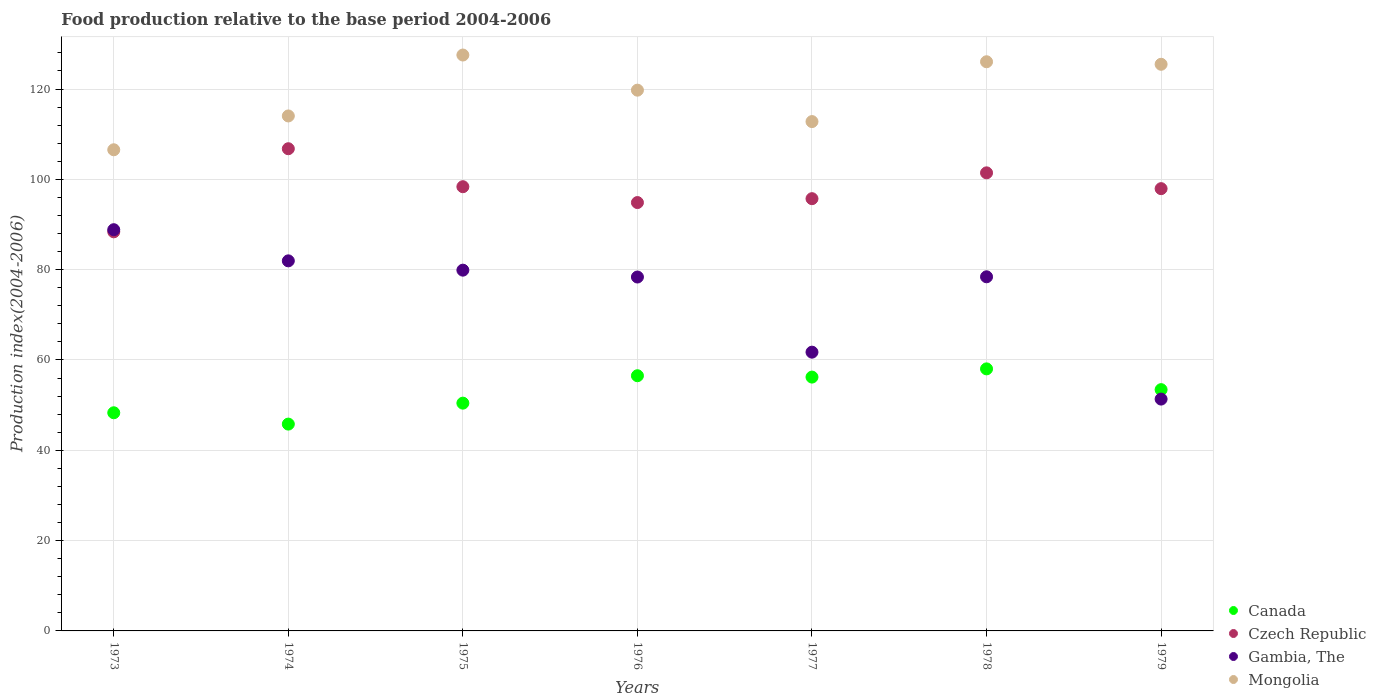What is the food production index in Gambia, The in 1976?
Keep it short and to the point. 78.37. Across all years, what is the maximum food production index in Czech Republic?
Give a very brief answer. 106.78. Across all years, what is the minimum food production index in Czech Republic?
Your response must be concise. 88.38. In which year was the food production index in Canada maximum?
Make the answer very short. 1978. What is the total food production index in Gambia, The in the graph?
Offer a terse response. 520.55. What is the difference between the food production index in Canada in 1973 and that in 1979?
Your answer should be very brief. -5.12. What is the difference between the food production index in Mongolia in 1978 and the food production index in Gambia, The in 1977?
Your response must be concise. 64.31. What is the average food production index in Czech Republic per year?
Your answer should be compact. 97.64. In the year 1978, what is the difference between the food production index in Czech Republic and food production index in Mongolia?
Provide a short and direct response. -24.6. What is the ratio of the food production index in Gambia, The in 1976 to that in 1977?
Ensure brevity in your answer.  1.27. Is the difference between the food production index in Czech Republic in 1974 and 1979 greater than the difference between the food production index in Mongolia in 1974 and 1979?
Your response must be concise. Yes. What is the difference between the highest and the second highest food production index in Mongolia?
Offer a very short reply. 1.49. What is the difference between the highest and the lowest food production index in Czech Republic?
Provide a succinct answer. 18.4. Is the sum of the food production index in Mongolia in 1973 and 1974 greater than the maximum food production index in Gambia, The across all years?
Make the answer very short. Yes. Is it the case that in every year, the sum of the food production index in Mongolia and food production index in Canada  is greater than the food production index in Czech Republic?
Provide a succinct answer. Yes. Is the food production index in Gambia, The strictly greater than the food production index in Czech Republic over the years?
Your response must be concise. No. How many years are there in the graph?
Offer a very short reply. 7. Does the graph contain grids?
Your response must be concise. Yes. Where does the legend appear in the graph?
Ensure brevity in your answer.  Bottom right. How are the legend labels stacked?
Ensure brevity in your answer.  Vertical. What is the title of the graph?
Ensure brevity in your answer.  Food production relative to the base period 2004-2006. Does "Indonesia" appear as one of the legend labels in the graph?
Provide a short and direct response. No. What is the label or title of the Y-axis?
Provide a short and direct response. Production index(2004-2006). What is the Production index(2004-2006) of Canada in 1973?
Provide a short and direct response. 48.31. What is the Production index(2004-2006) of Czech Republic in 1973?
Your response must be concise. 88.38. What is the Production index(2004-2006) in Gambia, The in 1973?
Give a very brief answer. 88.85. What is the Production index(2004-2006) in Mongolia in 1973?
Your answer should be very brief. 106.55. What is the Production index(2004-2006) in Canada in 1974?
Your answer should be very brief. 45.8. What is the Production index(2004-2006) in Czech Republic in 1974?
Ensure brevity in your answer.  106.78. What is the Production index(2004-2006) of Gambia, The in 1974?
Give a very brief answer. 81.95. What is the Production index(2004-2006) in Mongolia in 1974?
Provide a succinct answer. 114.04. What is the Production index(2004-2006) of Canada in 1975?
Provide a succinct answer. 50.44. What is the Production index(2004-2006) of Czech Republic in 1975?
Provide a succinct answer. 98.37. What is the Production index(2004-2006) of Gambia, The in 1975?
Your response must be concise. 79.89. What is the Production index(2004-2006) in Mongolia in 1975?
Keep it short and to the point. 127.53. What is the Production index(2004-2006) in Canada in 1976?
Provide a succinct answer. 56.51. What is the Production index(2004-2006) of Czech Republic in 1976?
Offer a very short reply. 94.86. What is the Production index(2004-2006) in Gambia, The in 1976?
Your answer should be compact. 78.37. What is the Production index(2004-2006) in Mongolia in 1976?
Provide a short and direct response. 119.75. What is the Production index(2004-2006) of Canada in 1977?
Keep it short and to the point. 56.21. What is the Production index(2004-2006) of Czech Republic in 1977?
Offer a terse response. 95.72. What is the Production index(2004-2006) in Gambia, The in 1977?
Provide a succinct answer. 61.73. What is the Production index(2004-2006) of Mongolia in 1977?
Offer a very short reply. 112.79. What is the Production index(2004-2006) of Canada in 1978?
Provide a short and direct response. 58.03. What is the Production index(2004-2006) of Czech Republic in 1978?
Keep it short and to the point. 101.44. What is the Production index(2004-2006) of Gambia, The in 1978?
Provide a short and direct response. 78.42. What is the Production index(2004-2006) of Mongolia in 1978?
Ensure brevity in your answer.  126.04. What is the Production index(2004-2006) in Canada in 1979?
Your response must be concise. 53.43. What is the Production index(2004-2006) in Czech Republic in 1979?
Your answer should be compact. 97.94. What is the Production index(2004-2006) in Gambia, The in 1979?
Your answer should be very brief. 51.34. What is the Production index(2004-2006) in Mongolia in 1979?
Provide a short and direct response. 125.48. Across all years, what is the maximum Production index(2004-2006) in Canada?
Make the answer very short. 58.03. Across all years, what is the maximum Production index(2004-2006) of Czech Republic?
Provide a short and direct response. 106.78. Across all years, what is the maximum Production index(2004-2006) of Gambia, The?
Your answer should be very brief. 88.85. Across all years, what is the maximum Production index(2004-2006) of Mongolia?
Your response must be concise. 127.53. Across all years, what is the minimum Production index(2004-2006) in Canada?
Your answer should be compact. 45.8. Across all years, what is the minimum Production index(2004-2006) of Czech Republic?
Your answer should be very brief. 88.38. Across all years, what is the minimum Production index(2004-2006) of Gambia, The?
Give a very brief answer. 51.34. Across all years, what is the minimum Production index(2004-2006) of Mongolia?
Your response must be concise. 106.55. What is the total Production index(2004-2006) in Canada in the graph?
Make the answer very short. 368.73. What is the total Production index(2004-2006) in Czech Republic in the graph?
Your response must be concise. 683.49. What is the total Production index(2004-2006) in Gambia, The in the graph?
Your answer should be compact. 520.55. What is the total Production index(2004-2006) of Mongolia in the graph?
Offer a terse response. 832.18. What is the difference between the Production index(2004-2006) in Canada in 1973 and that in 1974?
Offer a very short reply. 2.51. What is the difference between the Production index(2004-2006) in Czech Republic in 1973 and that in 1974?
Provide a short and direct response. -18.4. What is the difference between the Production index(2004-2006) in Gambia, The in 1973 and that in 1974?
Offer a terse response. 6.9. What is the difference between the Production index(2004-2006) in Mongolia in 1973 and that in 1974?
Offer a terse response. -7.49. What is the difference between the Production index(2004-2006) in Canada in 1973 and that in 1975?
Provide a short and direct response. -2.13. What is the difference between the Production index(2004-2006) in Czech Republic in 1973 and that in 1975?
Offer a terse response. -9.99. What is the difference between the Production index(2004-2006) of Gambia, The in 1973 and that in 1975?
Give a very brief answer. 8.96. What is the difference between the Production index(2004-2006) of Mongolia in 1973 and that in 1975?
Your answer should be very brief. -20.98. What is the difference between the Production index(2004-2006) of Canada in 1973 and that in 1976?
Provide a succinct answer. -8.2. What is the difference between the Production index(2004-2006) in Czech Republic in 1973 and that in 1976?
Provide a succinct answer. -6.48. What is the difference between the Production index(2004-2006) of Gambia, The in 1973 and that in 1976?
Give a very brief answer. 10.48. What is the difference between the Production index(2004-2006) of Mongolia in 1973 and that in 1976?
Keep it short and to the point. -13.2. What is the difference between the Production index(2004-2006) of Canada in 1973 and that in 1977?
Offer a terse response. -7.9. What is the difference between the Production index(2004-2006) in Czech Republic in 1973 and that in 1977?
Provide a succinct answer. -7.34. What is the difference between the Production index(2004-2006) in Gambia, The in 1973 and that in 1977?
Make the answer very short. 27.12. What is the difference between the Production index(2004-2006) of Mongolia in 1973 and that in 1977?
Ensure brevity in your answer.  -6.24. What is the difference between the Production index(2004-2006) of Canada in 1973 and that in 1978?
Your answer should be very brief. -9.72. What is the difference between the Production index(2004-2006) in Czech Republic in 1973 and that in 1978?
Give a very brief answer. -13.06. What is the difference between the Production index(2004-2006) in Gambia, The in 1973 and that in 1978?
Provide a short and direct response. 10.43. What is the difference between the Production index(2004-2006) in Mongolia in 1973 and that in 1978?
Your answer should be compact. -19.49. What is the difference between the Production index(2004-2006) in Canada in 1973 and that in 1979?
Ensure brevity in your answer.  -5.12. What is the difference between the Production index(2004-2006) of Czech Republic in 1973 and that in 1979?
Make the answer very short. -9.56. What is the difference between the Production index(2004-2006) of Gambia, The in 1973 and that in 1979?
Your answer should be compact. 37.51. What is the difference between the Production index(2004-2006) of Mongolia in 1973 and that in 1979?
Your response must be concise. -18.93. What is the difference between the Production index(2004-2006) of Canada in 1974 and that in 1975?
Offer a terse response. -4.64. What is the difference between the Production index(2004-2006) of Czech Republic in 1974 and that in 1975?
Keep it short and to the point. 8.41. What is the difference between the Production index(2004-2006) of Gambia, The in 1974 and that in 1975?
Your answer should be compact. 2.06. What is the difference between the Production index(2004-2006) of Mongolia in 1974 and that in 1975?
Make the answer very short. -13.49. What is the difference between the Production index(2004-2006) of Canada in 1974 and that in 1976?
Offer a terse response. -10.71. What is the difference between the Production index(2004-2006) of Czech Republic in 1974 and that in 1976?
Your answer should be compact. 11.92. What is the difference between the Production index(2004-2006) of Gambia, The in 1974 and that in 1976?
Your answer should be compact. 3.58. What is the difference between the Production index(2004-2006) of Mongolia in 1974 and that in 1976?
Offer a terse response. -5.71. What is the difference between the Production index(2004-2006) in Canada in 1974 and that in 1977?
Keep it short and to the point. -10.41. What is the difference between the Production index(2004-2006) of Czech Republic in 1974 and that in 1977?
Offer a terse response. 11.06. What is the difference between the Production index(2004-2006) in Gambia, The in 1974 and that in 1977?
Your answer should be very brief. 20.22. What is the difference between the Production index(2004-2006) in Mongolia in 1974 and that in 1977?
Provide a succinct answer. 1.25. What is the difference between the Production index(2004-2006) in Canada in 1974 and that in 1978?
Make the answer very short. -12.23. What is the difference between the Production index(2004-2006) of Czech Republic in 1974 and that in 1978?
Make the answer very short. 5.34. What is the difference between the Production index(2004-2006) of Gambia, The in 1974 and that in 1978?
Your response must be concise. 3.53. What is the difference between the Production index(2004-2006) of Canada in 1974 and that in 1979?
Provide a short and direct response. -7.63. What is the difference between the Production index(2004-2006) in Czech Republic in 1974 and that in 1979?
Your answer should be compact. 8.84. What is the difference between the Production index(2004-2006) in Gambia, The in 1974 and that in 1979?
Provide a short and direct response. 30.61. What is the difference between the Production index(2004-2006) of Mongolia in 1974 and that in 1979?
Your response must be concise. -11.44. What is the difference between the Production index(2004-2006) in Canada in 1975 and that in 1976?
Provide a short and direct response. -6.07. What is the difference between the Production index(2004-2006) in Czech Republic in 1975 and that in 1976?
Your answer should be very brief. 3.51. What is the difference between the Production index(2004-2006) in Gambia, The in 1975 and that in 1976?
Ensure brevity in your answer.  1.52. What is the difference between the Production index(2004-2006) in Mongolia in 1975 and that in 1976?
Offer a very short reply. 7.78. What is the difference between the Production index(2004-2006) of Canada in 1975 and that in 1977?
Your answer should be compact. -5.77. What is the difference between the Production index(2004-2006) in Czech Republic in 1975 and that in 1977?
Provide a succinct answer. 2.65. What is the difference between the Production index(2004-2006) in Gambia, The in 1975 and that in 1977?
Give a very brief answer. 18.16. What is the difference between the Production index(2004-2006) in Mongolia in 1975 and that in 1977?
Your answer should be very brief. 14.74. What is the difference between the Production index(2004-2006) in Canada in 1975 and that in 1978?
Provide a succinct answer. -7.59. What is the difference between the Production index(2004-2006) in Czech Republic in 1975 and that in 1978?
Your answer should be compact. -3.07. What is the difference between the Production index(2004-2006) of Gambia, The in 1975 and that in 1978?
Keep it short and to the point. 1.47. What is the difference between the Production index(2004-2006) in Mongolia in 1975 and that in 1978?
Keep it short and to the point. 1.49. What is the difference between the Production index(2004-2006) of Canada in 1975 and that in 1979?
Provide a short and direct response. -2.99. What is the difference between the Production index(2004-2006) of Czech Republic in 1975 and that in 1979?
Provide a succinct answer. 0.43. What is the difference between the Production index(2004-2006) of Gambia, The in 1975 and that in 1979?
Make the answer very short. 28.55. What is the difference between the Production index(2004-2006) of Mongolia in 1975 and that in 1979?
Give a very brief answer. 2.05. What is the difference between the Production index(2004-2006) of Canada in 1976 and that in 1977?
Your answer should be very brief. 0.3. What is the difference between the Production index(2004-2006) of Czech Republic in 1976 and that in 1977?
Your response must be concise. -0.86. What is the difference between the Production index(2004-2006) in Gambia, The in 1976 and that in 1977?
Ensure brevity in your answer.  16.64. What is the difference between the Production index(2004-2006) in Mongolia in 1976 and that in 1977?
Your answer should be compact. 6.96. What is the difference between the Production index(2004-2006) in Canada in 1976 and that in 1978?
Offer a terse response. -1.52. What is the difference between the Production index(2004-2006) of Czech Republic in 1976 and that in 1978?
Give a very brief answer. -6.58. What is the difference between the Production index(2004-2006) in Mongolia in 1976 and that in 1978?
Your answer should be compact. -6.29. What is the difference between the Production index(2004-2006) in Canada in 1976 and that in 1979?
Offer a very short reply. 3.08. What is the difference between the Production index(2004-2006) in Czech Republic in 1976 and that in 1979?
Make the answer very short. -3.08. What is the difference between the Production index(2004-2006) of Gambia, The in 1976 and that in 1979?
Your response must be concise. 27.03. What is the difference between the Production index(2004-2006) in Mongolia in 1976 and that in 1979?
Ensure brevity in your answer.  -5.73. What is the difference between the Production index(2004-2006) in Canada in 1977 and that in 1978?
Give a very brief answer. -1.82. What is the difference between the Production index(2004-2006) in Czech Republic in 1977 and that in 1978?
Your answer should be very brief. -5.72. What is the difference between the Production index(2004-2006) of Gambia, The in 1977 and that in 1978?
Make the answer very short. -16.69. What is the difference between the Production index(2004-2006) of Mongolia in 1977 and that in 1978?
Your response must be concise. -13.25. What is the difference between the Production index(2004-2006) of Canada in 1977 and that in 1979?
Offer a terse response. 2.78. What is the difference between the Production index(2004-2006) in Czech Republic in 1977 and that in 1979?
Ensure brevity in your answer.  -2.22. What is the difference between the Production index(2004-2006) in Gambia, The in 1977 and that in 1979?
Your answer should be very brief. 10.39. What is the difference between the Production index(2004-2006) in Mongolia in 1977 and that in 1979?
Your answer should be very brief. -12.69. What is the difference between the Production index(2004-2006) of Canada in 1978 and that in 1979?
Offer a very short reply. 4.6. What is the difference between the Production index(2004-2006) in Gambia, The in 1978 and that in 1979?
Your response must be concise. 27.08. What is the difference between the Production index(2004-2006) of Mongolia in 1978 and that in 1979?
Your answer should be very brief. 0.56. What is the difference between the Production index(2004-2006) in Canada in 1973 and the Production index(2004-2006) in Czech Republic in 1974?
Ensure brevity in your answer.  -58.47. What is the difference between the Production index(2004-2006) in Canada in 1973 and the Production index(2004-2006) in Gambia, The in 1974?
Your answer should be compact. -33.64. What is the difference between the Production index(2004-2006) of Canada in 1973 and the Production index(2004-2006) of Mongolia in 1974?
Offer a terse response. -65.73. What is the difference between the Production index(2004-2006) of Czech Republic in 1973 and the Production index(2004-2006) of Gambia, The in 1974?
Your answer should be very brief. 6.43. What is the difference between the Production index(2004-2006) of Czech Republic in 1973 and the Production index(2004-2006) of Mongolia in 1974?
Your answer should be very brief. -25.66. What is the difference between the Production index(2004-2006) in Gambia, The in 1973 and the Production index(2004-2006) in Mongolia in 1974?
Offer a terse response. -25.19. What is the difference between the Production index(2004-2006) in Canada in 1973 and the Production index(2004-2006) in Czech Republic in 1975?
Provide a short and direct response. -50.06. What is the difference between the Production index(2004-2006) in Canada in 1973 and the Production index(2004-2006) in Gambia, The in 1975?
Make the answer very short. -31.58. What is the difference between the Production index(2004-2006) of Canada in 1973 and the Production index(2004-2006) of Mongolia in 1975?
Give a very brief answer. -79.22. What is the difference between the Production index(2004-2006) in Czech Republic in 1973 and the Production index(2004-2006) in Gambia, The in 1975?
Provide a succinct answer. 8.49. What is the difference between the Production index(2004-2006) of Czech Republic in 1973 and the Production index(2004-2006) of Mongolia in 1975?
Provide a succinct answer. -39.15. What is the difference between the Production index(2004-2006) in Gambia, The in 1973 and the Production index(2004-2006) in Mongolia in 1975?
Offer a terse response. -38.68. What is the difference between the Production index(2004-2006) in Canada in 1973 and the Production index(2004-2006) in Czech Republic in 1976?
Offer a terse response. -46.55. What is the difference between the Production index(2004-2006) in Canada in 1973 and the Production index(2004-2006) in Gambia, The in 1976?
Provide a short and direct response. -30.06. What is the difference between the Production index(2004-2006) of Canada in 1973 and the Production index(2004-2006) of Mongolia in 1976?
Keep it short and to the point. -71.44. What is the difference between the Production index(2004-2006) of Czech Republic in 1973 and the Production index(2004-2006) of Gambia, The in 1976?
Offer a very short reply. 10.01. What is the difference between the Production index(2004-2006) of Czech Republic in 1973 and the Production index(2004-2006) of Mongolia in 1976?
Provide a short and direct response. -31.37. What is the difference between the Production index(2004-2006) of Gambia, The in 1973 and the Production index(2004-2006) of Mongolia in 1976?
Your answer should be very brief. -30.9. What is the difference between the Production index(2004-2006) of Canada in 1973 and the Production index(2004-2006) of Czech Republic in 1977?
Ensure brevity in your answer.  -47.41. What is the difference between the Production index(2004-2006) of Canada in 1973 and the Production index(2004-2006) of Gambia, The in 1977?
Offer a terse response. -13.42. What is the difference between the Production index(2004-2006) in Canada in 1973 and the Production index(2004-2006) in Mongolia in 1977?
Offer a terse response. -64.48. What is the difference between the Production index(2004-2006) of Czech Republic in 1973 and the Production index(2004-2006) of Gambia, The in 1977?
Your answer should be compact. 26.65. What is the difference between the Production index(2004-2006) of Czech Republic in 1973 and the Production index(2004-2006) of Mongolia in 1977?
Make the answer very short. -24.41. What is the difference between the Production index(2004-2006) of Gambia, The in 1973 and the Production index(2004-2006) of Mongolia in 1977?
Your response must be concise. -23.94. What is the difference between the Production index(2004-2006) in Canada in 1973 and the Production index(2004-2006) in Czech Republic in 1978?
Ensure brevity in your answer.  -53.13. What is the difference between the Production index(2004-2006) of Canada in 1973 and the Production index(2004-2006) of Gambia, The in 1978?
Your answer should be very brief. -30.11. What is the difference between the Production index(2004-2006) of Canada in 1973 and the Production index(2004-2006) of Mongolia in 1978?
Your answer should be very brief. -77.73. What is the difference between the Production index(2004-2006) of Czech Republic in 1973 and the Production index(2004-2006) of Gambia, The in 1978?
Your answer should be very brief. 9.96. What is the difference between the Production index(2004-2006) of Czech Republic in 1973 and the Production index(2004-2006) of Mongolia in 1978?
Provide a short and direct response. -37.66. What is the difference between the Production index(2004-2006) of Gambia, The in 1973 and the Production index(2004-2006) of Mongolia in 1978?
Provide a short and direct response. -37.19. What is the difference between the Production index(2004-2006) of Canada in 1973 and the Production index(2004-2006) of Czech Republic in 1979?
Your response must be concise. -49.63. What is the difference between the Production index(2004-2006) of Canada in 1973 and the Production index(2004-2006) of Gambia, The in 1979?
Ensure brevity in your answer.  -3.03. What is the difference between the Production index(2004-2006) in Canada in 1973 and the Production index(2004-2006) in Mongolia in 1979?
Give a very brief answer. -77.17. What is the difference between the Production index(2004-2006) in Czech Republic in 1973 and the Production index(2004-2006) in Gambia, The in 1979?
Give a very brief answer. 37.04. What is the difference between the Production index(2004-2006) in Czech Republic in 1973 and the Production index(2004-2006) in Mongolia in 1979?
Offer a very short reply. -37.1. What is the difference between the Production index(2004-2006) of Gambia, The in 1973 and the Production index(2004-2006) of Mongolia in 1979?
Offer a very short reply. -36.63. What is the difference between the Production index(2004-2006) of Canada in 1974 and the Production index(2004-2006) of Czech Republic in 1975?
Ensure brevity in your answer.  -52.57. What is the difference between the Production index(2004-2006) in Canada in 1974 and the Production index(2004-2006) in Gambia, The in 1975?
Offer a terse response. -34.09. What is the difference between the Production index(2004-2006) of Canada in 1974 and the Production index(2004-2006) of Mongolia in 1975?
Provide a succinct answer. -81.73. What is the difference between the Production index(2004-2006) of Czech Republic in 1974 and the Production index(2004-2006) of Gambia, The in 1975?
Give a very brief answer. 26.89. What is the difference between the Production index(2004-2006) in Czech Republic in 1974 and the Production index(2004-2006) in Mongolia in 1975?
Keep it short and to the point. -20.75. What is the difference between the Production index(2004-2006) of Gambia, The in 1974 and the Production index(2004-2006) of Mongolia in 1975?
Make the answer very short. -45.58. What is the difference between the Production index(2004-2006) of Canada in 1974 and the Production index(2004-2006) of Czech Republic in 1976?
Your answer should be very brief. -49.06. What is the difference between the Production index(2004-2006) in Canada in 1974 and the Production index(2004-2006) in Gambia, The in 1976?
Your answer should be compact. -32.57. What is the difference between the Production index(2004-2006) of Canada in 1974 and the Production index(2004-2006) of Mongolia in 1976?
Provide a succinct answer. -73.95. What is the difference between the Production index(2004-2006) of Czech Republic in 1974 and the Production index(2004-2006) of Gambia, The in 1976?
Ensure brevity in your answer.  28.41. What is the difference between the Production index(2004-2006) of Czech Republic in 1974 and the Production index(2004-2006) of Mongolia in 1976?
Offer a very short reply. -12.97. What is the difference between the Production index(2004-2006) in Gambia, The in 1974 and the Production index(2004-2006) in Mongolia in 1976?
Provide a succinct answer. -37.8. What is the difference between the Production index(2004-2006) in Canada in 1974 and the Production index(2004-2006) in Czech Republic in 1977?
Your answer should be compact. -49.92. What is the difference between the Production index(2004-2006) in Canada in 1974 and the Production index(2004-2006) in Gambia, The in 1977?
Provide a short and direct response. -15.93. What is the difference between the Production index(2004-2006) of Canada in 1974 and the Production index(2004-2006) of Mongolia in 1977?
Offer a terse response. -66.99. What is the difference between the Production index(2004-2006) in Czech Republic in 1974 and the Production index(2004-2006) in Gambia, The in 1977?
Offer a very short reply. 45.05. What is the difference between the Production index(2004-2006) in Czech Republic in 1974 and the Production index(2004-2006) in Mongolia in 1977?
Offer a terse response. -6.01. What is the difference between the Production index(2004-2006) in Gambia, The in 1974 and the Production index(2004-2006) in Mongolia in 1977?
Offer a terse response. -30.84. What is the difference between the Production index(2004-2006) of Canada in 1974 and the Production index(2004-2006) of Czech Republic in 1978?
Your answer should be compact. -55.64. What is the difference between the Production index(2004-2006) in Canada in 1974 and the Production index(2004-2006) in Gambia, The in 1978?
Offer a terse response. -32.62. What is the difference between the Production index(2004-2006) in Canada in 1974 and the Production index(2004-2006) in Mongolia in 1978?
Provide a short and direct response. -80.24. What is the difference between the Production index(2004-2006) of Czech Republic in 1974 and the Production index(2004-2006) of Gambia, The in 1978?
Offer a terse response. 28.36. What is the difference between the Production index(2004-2006) of Czech Republic in 1974 and the Production index(2004-2006) of Mongolia in 1978?
Your answer should be compact. -19.26. What is the difference between the Production index(2004-2006) in Gambia, The in 1974 and the Production index(2004-2006) in Mongolia in 1978?
Provide a succinct answer. -44.09. What is the difference between the Production index(2004-2006) of Canada in 1974 and the Production index(2004-2006) of Czech Republic in 1979?
Your answer should be very brief. -52.14. What is the difference between the Production index(2004-2006) of Canada in 1974 and the Production index(2004-2006) of Gambia, The in 1979?
Your answer should be compact. -5.54. What is the difference between the Production index(2004-2006) in Canada in 1974 and the Production index(2004-2006) in Mongolia in 1979?
Keep it short and to the point. -79.68. What is the difference between the Production index(2004-2006) of Czech Republic in 1974 and the Production index(2004-2006) of Gambia, The in 1979?
Your response must be concise. 55.44. What is the difference between the Production index(2004-2006) of Czech Republic in 1974 and the Production index(2004-2006) of Mongolia in 1979?
Keep it short and to the point. -18.7. What is the difference between the Production index(2004-2006) of Gambia, The in 1974 and the Production index(2004-2006) of Mongolia in 1979?
Your response must be concise. -43.53. What is the difference between the Production index(2004-2006) of Canada in 1975 and the Production index(2004-2006) of Czech Republic in 1976?
Keep it short and to the point. -44.42. What is the difference between the Production index(2004-2006) in Canada in 1975 and the Production index(2004-2006) in Gambia, The in 1976?
Ensure brevity in your answer.  -27.93. What is the difference between the Production index(2004-2006) in Canada in 1975 and the Production index(2004-2006) in Mongolia in 1976?
Provide a short and direct response. -69.31. What is the difference between the Production index(2004-2006) of Czech Republic in 1975 and the Production index(2004-2006) of Gambia, The in 1976?
Ensure brevity in your answer.  20. What is the difference between the Production index(2004-2006) in Czech Republic in 1975 and the Production index(2004-2006) in Mongolia in 1976?
Offer a very short reply. -21.38. What is the difference between the Production index(2004-2006) of Gambia, The in 1975 and the Production index(2004-2006) of Mongolia in 1976?
Provide a short and direct response. -39.86. What is the difference between the Production index(2004-2006) in Canada in 1975 and the Production index(2004-2006) in Czech Republic in 1977?
Give a very brief answer. -45.28. What is the difference between the Production index(2004-2006) in Canada in 1975 and the Production index(2004-2006) in Gambia, The in 1977?
Keep it short and to the point. -11.29. What is the difference between the Production index(2004-2006) in Canada in 1975 and the Production index(2004-2006) in Mongolia in 1977?
Your response must be concise. -62.35. What is the difference between the Production index(2004-2006) in Czech Republic in 1975 and the Production index(2004-2006) in Gambia, The in 1977?
Offer a very short reply. 36.64. What is the difference between the Production index(2004-2006) of Czech Republic in 1975 and the Production index(2004-2006) of Mongolia in 1977?
Keep it short and to the point. -14.42. What is the difference between the Production index(2004-2006) of Gambia, The in 1975 and the Production index(2004-2006) of Mongolia in 1977?
Ensure brevity in your answer.  -32.9. What is the difference between the Production index(2004-2006) in Canada in 1975 and the Production index(2004-2006) in Czech Republic in 1978?
Keep it short and to the point. -51. What is the difference between the Production index(2004-2006) of Canada in 1975 and the Production index(2004-2006) of Gambia, The in 1978?
Provide a succinct answer. -27.98. What is the difference between the Production index(2004-2006) of Canada in 1975 and the Production index(2004-2006) of Mongolia in 1978?
Your response must be concise. -75.6. What is the difference between the Production index(2004-2006) in Czech Republic in 1975 and the Production index(2004-2006) in Gambia, The in 1978?
Your answer should be very brief. 19.95. What is the difference between the Production index(2004-2006) of Czech Republic in 1975 and the Production index(2004-2006) of Mongolia in 1978?
Keep it short and to the point. -27.67. What is the difference between the Production index(2004-2006) in Gambia, The in 1975 and the Production index(2004-2006) in Mongolia in 1978?
Offer a terse response. -46.15. What is the difference between the Production index(2004-2006) in Canada in 1975 and the Production index(2004-2006) in Czech Republic in 1979?
Make the answer very short. -47.5. What is the difference between the Production index(2004-2006) of Canada in 1975 and the Production index(2004-2006) of Mongolia in 1979?
Keep it short and to the point. -75.04. What is the difference between the Production index(2004-2006) in Czech Republic in 1975 and the Production index(2004-2006) in Gambia, The in 1979?
Provide a succinct answer. 47.03. What is the difference between the Production index(2004-2006) of Czech Republic in 1975 and the Production index(2004-2006) of Mongolia in 1979?
Your answer should be very brief. -27.11. What is the difference between the Production index(2004-2006) in Gambia, The in 1975 and the Production index(2004-2006) in Mongolia in 1979?
Provide a short and direct response. -45.59. What is the difference between the Production index(2004-2006) in Canada in 1976 and the Production index(2004-2006) in Czech Republic in 1977?
Your answer should be compact. -39.21. What is the difference between the Production index(2004-2006) in Canada in 1976 and the Production index(2004-2006) in Gambia, The in 1977?
Provide a succinct answer. -5.22. What is the difference between the Production index(2004-2006) of Canada in 1976 and the Production index(2004-2006) of Mongolia in 1977?
Ensure brevity in your answer.  -56.28. What is the difference between the Production index(2004-2006) in Czech Republic in 1976 and the Production index(2004-2006) in Gambia, The in 1977?
Ensure brevity in your answer.  33.13. What is the difference between the Production index(2004-2006) of Czech Republic in 1976 and the Production index(2004-2006) of Mongolia in 1977?
Provide a succinct answer. -17.93. What is the difference between the Production index(2004-2006) of Gambia, The in 1976 and the Production index(2004-2006) of Mongolia in 1977?
Provide a succinct answer. -34.42. What is the difference between the Production index(2004-2006) of Canada in 1976 and the Production index(2004-2006) of Czech Republic in 1978?
Your answer should be compact. -44.93. What is the difference between the Production index(2004-2006) in Canada in 1976 and the Production index(2004-2006) in Gambia, The in 1978?
Your answer should be compact. -21.91. What is the difference between the Production index(2004-2006) in Canada in 1976 and the Production index(2004-2006) in Mongolia in 1978?
Give a very brief answer. -69.53. What is the difference between the Production index(2004-2006) of Czech Republic in 1976 and the Production index(2004-2006) of Gambia, The in 1978?
Provide a succinct answer. 16.44. What is the difference between the Production index(2004-2006) of Czech Republic in 1976 and the Production index(2004-2006) of Mongolia in 1978?
Make the answer very short. -31.18. What is the difference between the Production index(2004-2006) in Gambia, The in 1976 and the Production index(2004-2006) in Mongolia in 1978?
Make the answer very short. -47.67. What is the difference between the Production index(2004-2006) of Canada in 1976 and the Production index(2004-2006) of Czech Republic in 1979?
Your answer should be very brief. -41.43. What is the difference between the Production index(2004-2006) of Canada in 1976 and the Production index(2004-2006) of Gambia, The in 1979?
Provide a succinct answer. 5.17. What is the difference between the Production index(2004-2006) in Canada in 1976 and the Production index(2004-2006) in Mongolia in 1979?
Your answer should be compact. -68.97. What is the difference between the Production index(2004-2006) in Czech Republic in 1976 and the Production index(2004-2006) in Gambia, The in 1979?
Keep it short and to the point. 43.52. What is the difference between the Production index(2004-2006) in Czech Republic in 1976 and the Production index(2004-2006) in Mongolia in 1979?
Provide a short and direct response. -30.62. What is the difference between the Production index(2004-2006) of Gambia, The in 1976 and the Production index(2004-2006) of Mongolia in 1979?
Make the answer very short. -47.11. What is the difference between the Production index(2004-2006) of Canada in 1977 and the Production index(2004-2006) of Czech Republic in 1978?
Your response must be concise. -45.23. What is the difference between the Production index(2004-2006) of Canada in 1977 and the Production index(2004-2006) of Gambia, The in 1978?
Make the answer very short. -22.21. What is the difference between the Production index(2004-2006) of Canada in 1977 and the Production index(2004-2006) of Mongolia in 1978?
Offer a terse response. -69.83. What is the difference between the Production index(2004-2006) in Czech Republic in 1977 and the Production index(2004-2006) in Mongolia in 1978?
Keep it short and to the point. -30.32. What is the difference between the Production index(2004-2006) of Gambia, The in 1977 and the Production index(2004-2006) of Mongolia in 1978?
Make the answer very short. -64.31. What is the difference between the Production index(2004-2006) in Canada in 1977 and the Production index(2004-2006) in Czech Republic in 1979?
Offer a terse response. -41.73. What is the difference between the Production index(2004-2006) of Canada in 1977 and the Production index(2004-2006) of Gambia, The in 1979?
Provide a short and direct response. 4.87. What is the difference between the Production index(2004-2006) of Canada in 1977 and the Production index(2004-2006) of Mongolia in 1979?
Your answer should be very brief. -69.27. What is the difference between the Production index(2004-2006) in Czech Republic in 1977 and the Production index(2004-2006) in Gambia, The in 1979?
Your response must be concise. 44.38. What is the difference between the Production index(2004-2006) of Czech Republic in 1977 and the Production index(2004-2006) of Mongolia in 1979?
Ensure brevity in your answer.  -29.76. What is the difference between the Production index(2004-2006) in Gambia, The in 1977 and the Production index(2004-2006) in Mongolia in 1979?
Offer a terse response. -63.75. What is the difference between the Production index(2004-2006) in Canada in 1978 and the Production index(2004-2006) in Czech Republic in 1979?
Keep it short and to the point. -39.91. What is the difference between the Production index(2004-2006) in Canada in 1978 and the Production index(2004-2006) in Gambia, The in 1979?
Give a very brief answer. 6.69. What is the difference between the Production index(2004-2006) in Canada in 1978 and the Production index(2004-2006) in Mongolia in 1979?
Provide a succinct answer. -67.45. What is the difference between the Production index(2004-2006) of Czech Republic in 1978 and the Production index(2004-2006) of Gambia, The in 1979?
Offer a very short reply. 50.1. What is the difference between the Production index(2004-2006) in Czech Republic in 1978 and the Production index(2004-2006) in Mongolia in 1979?
Your answer should be very brief. -24.04. What is the difference between the Production index(2004-2006) of Gambia, The in 1978 and the Production index(2004-2006) of Mongolia in 1979?
Keep it short and to the point. -47.06. What is the average Production index(2004-2006) of Canada per year?
Offer a terse response. 52.68. What is the average Production index(2004-2006) of Czech Republic per year?
Keep it short and to the point. 97.64. What is the average Production index(2004-2006) in Gambia, The per year?
Keep it short and to the point. 74.36. What is the average Production index(2004-2006) of Mongolia per year?
Give a very brief answer. 118.88. In the year 1973, what is the difference between the Production index(2004-2006) of Canada and Production index(2004-2006) of Czech Republic?
Your answer should be very brief. -40.07. In the year 1973, what is the difference between the Production index(2004-2006) of Canada and Production index(2004-2006) of Gambia, The?
Your response must be concise. -40.54. In the year 1973, what is the difference between the Production index(2004-2006) in Canada and Production index(2004-2006) in Mongolia?
Your answer should be very brief. -58.24. In the year 1973, what is the difference between the Production index(2004-2006) of Czech Republic and Production index(2004-2006) of Gambia, The?
Offer a very short reply. -0.47. In the year 1973, what is the difference between the Production index(2004-2006) of Czech Republic and Production index(2004-2006) of Mongolia?
Your answer should be compact. -18.17. In the year 1973, what is the difference between the Production index(2004-2006) of Gambia, The and Production index(2004-2006) of Mongolia?
Keep it short and to the point. -17.7. In the year 1974, what is the difference between the Production index(2004-2006) in Canada and Production index(2004-2006) in Czech Republic?
Keep it short and to the point. -60.98. In the year 1974, what is the difference between the Production index(2004-2006) in Canada and Production index(2004-2006) in Gambia, The?
Offer a terse response. -36.15. In the year 1974, what is the difference between the Production index(2004-2006) in Canada and Production index(2004-2006) in Mongolia?
Your answer should be very brief. -68.24. In the year 1974, what is the difference between the Production index(2004-2006) in Czech Republic and Production index(2004-2006) in Gambia, The?
Make the answer very short. 24.83. In the year 1974, what is the difference between the Production index(2004-2006) of Czech Republic and Production index(2004-2006) of Mongolia?
Offer a very short reply. -7.26. In the year 1974, what is the difference between the Production index(2004-2006) of Gambia, The and Production index(2004-2006) of Mongolia?
Your answer should be compact. -32.09. In the year 1975, what is the difference between the Production index(2004-2006) of Canada and Production index(2004-2006) of Czech Republic?
Keep it short and to the point. -47.93. In the year 1975, what is the difference between the Production index(2004-2006) in Canada and Production index(2004-2006) in Gambia, The?
Keep it short and to the point. -29.45. In the year 1975, what is the difference between the Production index(2004-2006) of Canada and Production index(2004-2006) of Mongolia?
Your answer should be very brief. -77.09. In the year 1975, what is the difference between the Production index(2004-2006) in Czech Republic and Production index(2004-2006) in Gambia, The?
Provide a succinct answer. 18.48. In the year 1975, what is the difference between the Production index(2004-2006) in Czech Republic and Production index(2004-2006) in Mongolia?
Provide a short and direct response. -29.16. In the year 1975, what is the difference between the Production index(2004-2006) in Gambia, The and Production index(2004-2006) in Mongolia?
Offer a terse response. -47.64. In the year 1976, what is the difference between the Production index(2004-2006) of Canada and Production index(2004-2006) of Czech Republic?
Ensure brevity in your answer.  -38.35. In the year 1976, what is the difference between the Production index(2004-2006) in Canada and Production index(2004-2006) in Gambia, The?
Offer a terse response. -21.86. In the year 1976, what is the difference between the Production index(2004-2006) in Canada and Production index(2004-2006) in Mongolia?
Your response must be concise. -63.24. In the year 1976, what is the difference between the Production index(2004-2006) of Czech Republic and Production index(2004-2006) of Gambia, The?
Provide a succinct answer. 16.49. In the year 1976, what is the difference between the Production index(2004-2006) of Czech Republic and Production index(2004-2006) of Mongolia?
Offer a terse response. -24.89. In the year 1976, what is the difference between the Production index(2004-2006) in Gambia, The and Production index(2004-2006) in Mongolia?
Give a very brief answer. -41.38. In the year 1977, what is the difference between the Production index(2004-2006) of Canada and Production index(2004-2006) of Czech Republic?
Make the answer very short. -39.51. In the year 1977, what is the difference between the Production index(2004-2006) in Canada and Production index(2004-2006) in Gambia, The?
Offer a very short reply. -5.52. In the year 1977, what is the difference between the Production index(2004-2006) in Canada and Production index(2004-2006) in Mongolia?
Ensure brevity in your answer.  -56.58. In the year 1977, what is the difference between the Production index(2004-2006) in Czech Republic and Production index(2004-2006) in Gambia, The?
Give a very brief answer. 33.99. In the year 1977, what is the difference between the Production index(2004-2006) in Czech Republic and Production index(2004-2006) in Mongolia?
Offer a very short reply. -17.07. In the year 1977, what is the difference between the Production index(2004-2006) in Gambia, The and Production index(2004-2006) in Mongolia?
Offer a terse response. -51.06. In the year 1978, what is the difference between the Production index(2004-2006) of Canada and Production index(2004-2006) of Czech Republic?
Keep it short and to the point. -43.41. In the year 1978, what is the difference between the Production index(2004-2006) in Canada and Production index(2004-2006) in Gambia, The?
Give a very brief answer. -20.39. In the year 1978, what is the difference between the Production index(2004-2006) of Canada and Production index(2004-2006) of Mongolia?
Ensure brevity in your answer.  -68.01. In the year 1978, what is the difference between the Production index(2004-2006) of Czech Republic and Production index(2004-2006) of Gambia, The?
Provide a short and direct response. 23.02. In the year 1978, what is the difference between the Production index(2004-2006) in Czech Republic and Production index(2004-2006) in Mongolia?
Ensure brevity in your answer.  -24.6. In the year 1978, what is the difference between the Production index(2004-2006) of Gambia, The and Production index(2004-2006) of Mongolia?
Give a very brief answer. -47.62. In the year 1979, what is the difference between the Production index(2004-2006) of Canada and Production index(2004-2006) of Czech Republic?
Make the answer very short. -44.51. In the year 1979, what is the difference between the Production index(2004-2006) in Canada and Production index(2004-2006) in Gambia, The?
Your response must be concise. 2.09. In the year 1979, what is the difference between the Production index(2004-2006) in Canada and Production index(2004-2006) in Mongolia?
Provide a succinct answer. -72.05. In the year 1979, what is the difference between the Production index(2004-2006) in Czech Republic and Production index(2004-2006) in Gambia, The?
Keep it short and to the point. 46.6. In the year 1979, what is the difference between the Production index(2004-2006) in Czech Republic and Production index(2004-2006) in Mongolia?
Make the answer very short. -27.54. In the year 1979, what is the difference between the Production index(2004-2006) in Gambia, The and Production index(2004-2006) in Mongolia?
Your answer should be very brief. -74.14. What is the ratio of the Production index(2004-2006) in Canada in 1973 to that in 1974?
Your answer should be compact. 1.05. What is the ratio of the Production index(2004-2006) of Czech Republic in 1973 to that in 1974?
Give a very brief answer. 0.83. What is the ratio of the Production index(2004-2006) of Gambia, The in 1973 to that in 1974?
Provide a short and direct response. 1.08. What is the ratio of the Production index(2004-2006) of Mongolia in 1973 to that in 1974?
Give a very brief answer. 0.93. What is the ratio of the Production index(2004-2006) in Canada in 1973 to that in 1975?
Provide a short and direct response. 0.96. What is the ratio of the Production index(2004-2006) of Czech Republic in 1973 to that in 1975?
Ensure brevity in your answer.  0.9. What is the ratio of the Production index(2004-2006) in Gambia, The in 1973 to that in 1975?
Provide a succinct answer. 1.11. What is the ratio of the Production index(2004-2006) of Mongolia in 1973 to that in 1975?
Your answer should be very brief. 0.84. What is the ratio of the Production index(2004-2006) in Canada in 1973 to that in 1976?
Keep it short and to the point. 0.85. What is the ratio of the Production index(2004-2006) of Czech Republic in 1973 to that in 1976?
Your answer should be compact. 0.93. What is the ratio of the Production index(2004-2006) in Gambia, The in 1973 to that in 1976?
Ensure brevity in your answer.  1.13. What is the ratio of the Production index(2004-2006) of Mongolia in 1973 to that in 1976?
Give a very brief answer. 0.89. What is the ratio of the Production index(2004-2006) of Canada in 1973 to that in 1977?
Ensure brevity in your answer.  0.86. What is the ratio of the Production index(2004-2006) in Czech Republic in 1973 to that in 1977?
Offer a very short reply. 0.92. What is the ratio of the Production index(2004-2006) in Gambia, The in 1973 to that in 1977?
Make the answer very short. 1.44. What is the ratio of the Production index(2004-2006) of Mongolia in 1973 to that in 1977?
Offer a very short reply. 0.94. What is the ratio of the Production index(2004-2006) of Canada in 1973 to that in 1978?
Your answer should be very brief. 0.83. What is the ratio of the Production index(2004-2006) in Czech Republic in 1973 to that in 1978?
Keep it short and to the point. 0.87. What is the ratio of the Production index(2004-2006) in Gambia, The in 1973 to that in 1978?
Your response must be concise. 1.13. What is the ratio of the Production index(2004-2006) in Mongolia in 1973 to that in 1978?
Provide a short and direct response. 0.85. What is the ratio of the Production index(2004-2006) in Canada in 1973 to that in 1979?
Provide a succinct answer. 0.9. What is the ratio of the Production index(2004-2006) in Czech Republic in 1973 to that in 1979?
Ensure brevity in your answer.  0.9. What is the ratio of the Production index(2004-2006) of Gambia, The in 1973 to that in 1979?
Offer a very short reply. 1.73. What is the ratio of the Production index(2004-2006) in Mongolia in 1973 to that in 1979?
Keep it short and to the point. 0.85. What is the ratio of the Production index(2004-2006) of Canada in 1974 to that in 1975?
Offer a terse response. 0.91. What is the ratio of the Production index(2004-2006) of Czech Republic in 1974 to that in 1975?
Your answer should be compact. 1.09. What is the ratio of the Production index(2004-2006) in Gambia, The in 1974 to that in 1975?
Ensure brevity in your answer.  1.03. What is the ratio of the Production index(2004-2006) in Mongolia in 1974 to that in 1975?
Make the answer very short. 0.89. What is the ratio of the Production index(2004-2006) in Canada in 1974 to that in 1976?
Offer a terse response. 0.81. What is the ratio of the Production index(2004-2006) of Czech Republic in 1974 to that in 1976?
Provide a short and direct response. 1.13. What is the ratio of the Production index(2004-2006) of Gambia, The in 1974 to that in 1976?
Your answer should be very brief. 1.05. What is the ratio of the Production index(2004-2006) of Mongolia in 1974 to that in 1976?
Your response must be concise. 0.95. What is the ratio of the Production index(2004-2006) of Canada in 1974 to that in 1977?
Ensure brevity in your answer.  0.81. What is the ratio of the Production index(2004-2006) of Czech Republic in 1974 to that in 1977?
Offer a very short reply. 1.12. What is the ratio of the Production index(2004-2006) of Gambia, The in 1974 to that in 1977?
Your response must be concise. 1.33. What is the ratio of the Production index(2004-2006) of Mongolia in 1974 to that in 1977?
Your response must be concise. 1.01. What is the ratio of the Production index(2004-2006) in Canada in 1974 to that in 1978?
Keep it short and to the point. 0.79. What is the ratio of the Production index(2004-2006) in Czech Republic in 1974 to that in 1978?
Your response must be concise. 1.05. What is the ratio of the Production index(2004-2006) in Gambia, The in 1974 to that in 1978?
Offer a very short reply. 1.04. What is the ratio of the Production index(2004-2006) of Mongolia in 1974 to that in 1978?
Keep it short and to the point. 0.9. What is the ratio of the Production index(2004-2006) of Canada in 1974 to that in 1979?
Offer a very short reply. 0.86. What is the ratio of the Production index(2004-2006) of Czech Republic in 1974 to that in 1979?
Give a very brief answer. 1.09. What is the ratio of the Production index(2004-2006) of Gambia, The in 1974 to that in 1979?
Provide a short and direct response. 1.6. What is the ratio of the Production index(2004-2006) of Mongolia in 1974 to that in 1979?
Offer a terse response. 0.91. What is the ratio of the Production index(2004-2006) in Canada in 1975 to that in 1976?
Your answer should be compact. 0.89. What is the ratio of the Production index(2004-2006) of Gambia, The in 1975 to that in 1976?
Keep it short and to the point. 1.02. What is the ratio of the Production index(2004-2006) of Mongolia in 1975 to that in 1976?
Your answer should be very brief. 1.06. What is the ratio of the Production index(2004-2006) of Canada in 1975 to that in 1977?
Offer a very short reply. 0.9. What is the ratio of the Production index(2004-2006) in Czech Republic in 1975 to that in 1977?
Make the answer very short. 1.03. What is the ratio of the Production index(2004-2006) in Gambia, The in 1975 to that in 1977?
Offer a very short reply. 1.29. What is the ratio of the Production index(2004-2006) of Mongolia in 1975 to that in 1977?
Give a very brief answer. 1.13. What is the ratio of the Production index(2004-2006) in Canada in 1975 to that in 1978?
Your answer should be compact. 0.87. What is the ratio of the Production index(2004-2006) of Czech Republic in 1975 to that in 1978?
Make the answer very short. 0.97. What is the ratio of the Production index(2004-2006) in Gambia, The in 1975 to that in 1978?
Give a very brief answer. 1.02. What is the ratio of the Production index(2004-2006) in Mongolia in 1975 to that in 1978?
Keep it short and to the point. 1.01. What is the ratio of the Production index(2004-2006) in Canada in 1975 to that in 1979?
Keep it short and to the point. 0.94. What is the ratio of the Production index(2004-2006) in Czech Republic in 1975 to that in 1979?
Your answer should be compact. 1. What is the ratio of the Production index(2004-2006) in Gambia, The in 1975 to that in 1979?
Offer a terse response. 1.56. What is the ratio of the Production index(2004-2006) of Mongolia in 1975 to that in 1979?
Ensure brevity in your answer.  1.02. What is the ratio of the Production index(2004-2006) in Canada in 1976 to that in 1977?
Keep it short and to the point. 1.01. What is the ratio of the Production index(2004-2006) of Czech Republic in 1976 to that in 1977?
Your answer should be very brief. 0.99. What is the ratio of the Production index(2004-2006) of Gambia, The in 1976 to that in 1977?
Your answer should be compact. 1.27. What is the ratio of the Production index(2004-2006) of Mongolia in 1976 to that in 1977?
Offer a terse response. 1.06. What is the ratio of the Production index(2004-2006) of Canada in 1976 to that in 1978?
Your answer should be very brief. 0.97. What is the ratio of the Production index(2004-2006) of Czech Republic in 1976 to that in 1978?
Make the answer very short. 0.94. What is the ratio of the Production index(2004-2006) of Gambia, The in 1976 to that in 1978?
Ensure brevity in your answer.  1. What is the ratio of the Production index(2004-2006) in Mongolia in 1976 to that in 1978?
Make the answer very short. 0.95. What is the ratio of the Production index(2004-2006) in Canada in 1976 to that in 1979?
Give a very brief answer. 1.06. What is the ratio of the Production index(2004-2006) in Czech Republic in 1976 to that in 1979?
Your answer should be very brief. 0.97. What is the ratio of the Production index(2004-2006) of Gambia, The in 1976 to that in 1979?
Give a very brief answer. 1.53. What is the ratio of the Production index(2004-2006) in Mongolia in 1976 to that in 1979?
Your answer should be compact. 0.95. What is the ratio of the Production index(2004-2006) in Canada in 1977 to that in 1978?
Keep it short and to the point. 0.97. What is the ratio of the Production index(2004-2006) in Czech Republic in 1977 to that in 1978?
Offer a very short reply. 0.94. What is the ratio of the Production index(2004-2006) of Gambia, The in 1977 to that in 1978?
Make the answer very short. 0.79. What is the ratio of the Production index(2004-2006) of Mongolia in 1977 to that in 1978?
Offer a very short reply. 0.89. What is the ratio of the Production index(2004-2006) in Canada in 1977 to that in 1979?
Ensure brevity in your answer.  1.05. What is the ratio of the Production index(2004-2006) in Czech Republic in 1977 to that in 1979?
Your answer should be very brief. 0.98. What is the ratio of the Production index(2004-2006) in Gambia, The in 1977 to that in 1979?
Give a very brief answer. 1.2. What is the ratio of the Production index(2004-2006) in Mongolia in 1977 to that in 1979?
Provide a succinct answer. 0.9. What is the ratio of the Production index(2004-2006) of Canada in 1978 to that in 1979?
Make the answer very short. 1.09. What is the ratio of the Production index(2004-2006) of Czech Republic in 1978 to that in 1979?
Provide a short and direct response. 1.04. What is the ratio of the Production index(2004-2006) in Gambia, The in 1978 to that in 1979?
Provide a short and direct response. 1.53. What is the ratio of the Production index(2004-2006) in Mongolia in 1978 to that in 1979?
Make the answer very short. 1. What is the difference between the highest and the second highest Production index(2004-2006) in Canada?
Make the answer very short. 1.52. What is the difference between the highest and the second highest Production index(2004-2006) in Czech Republic?
Give a very brief answer. 5.34. What is the difference between the highest and the second highest Production index(2004-2006) in Mongolia?
Ensure brevity in your answer.  1.49. What is the difference between the highest and the lowest Production index(2004-2006) of Canada?
Provide a succinct answer. 12.23. What is the difference between the highest and the lowest Production index(2004-2006) of Czech Republic?
Your answer should be compact. 18.4. What is the difference between the highest and the lowest Production index(2004-2006) in Gambia, The?
Make the answer very short. 37.51. What is the difference between the highest and the lowest Production index(2004-2006) in Mongolia?
Keep it short and to the point. 20.98. 